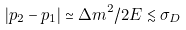Convert formula to latex. <formula><loc_0><loc_0><loc_500><loc_500>| p _ { 2 } - p _ { 1 } | \simeq \Delta m ^ { 2 } / 2 E \lesssim \sigma _ { D }</formula> 